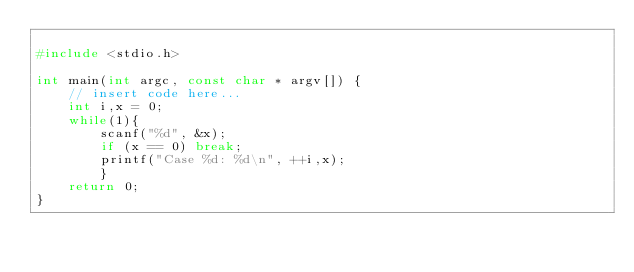Convert code to text. <code><loc_0><loc_0><loc_500><loc_500><_C_>
#include <stdio.h>

int main(int argc, const char * argv[]) {
    // insert code here...
    int i,x = 0;
    while(1){
        scanf("%d", &x);
        if (x == 0) break;
        printf("Case %d: %d\n", ++i,x);
        }
    return 0;
}</code> 